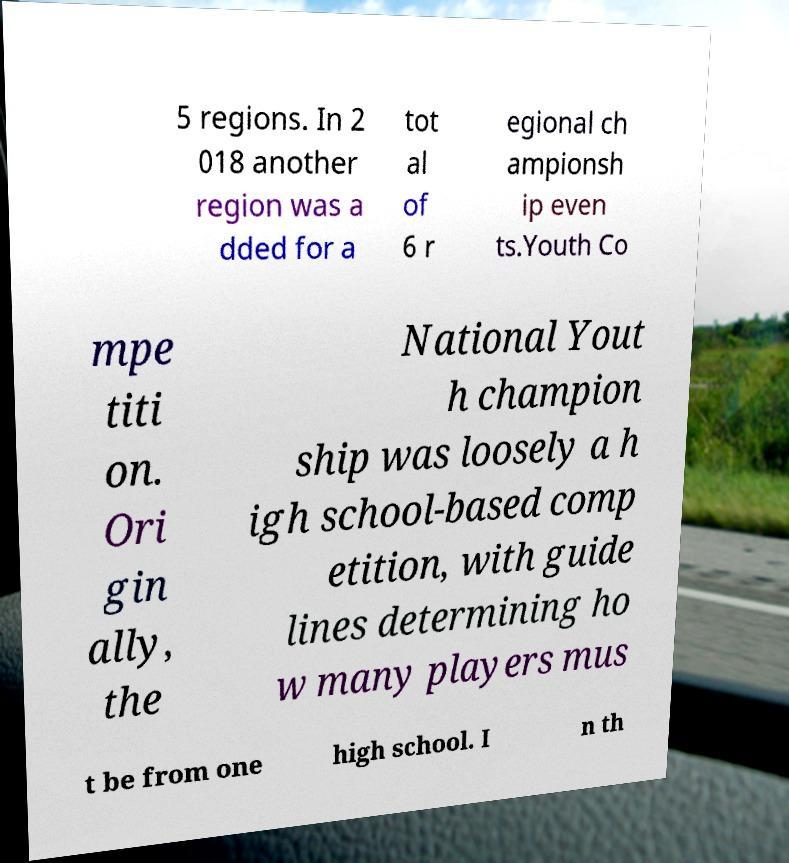Could you extract and type out the text from this image? 5 regions. In 2 018 another region was a dded for a tot al of 6 r egional ch ampionsh ip even ts.Youth Co mpe titi on. Ori gin ally, the National Yout h champion ship was loosely a h igh school-based comp etition, with guide lines determining ho w many players mus t be from one high school. I n th 